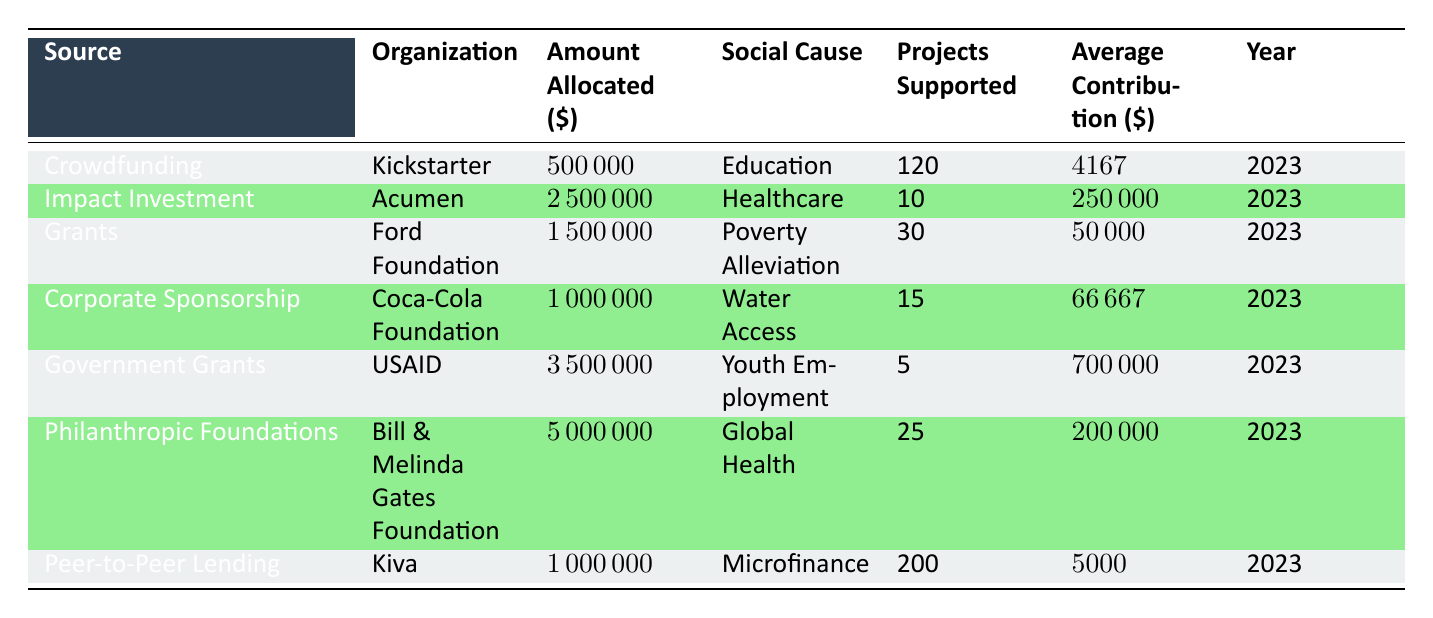What is the total amount allocated across all funding sources? To find the total amount allocated, we need to sum the Amount Allocated for each funding source. Adding them gives: 500000 + 2500000 + 1500000 + 1000000 + 3500000 + 5000000 + 1000000 = 15000000.
Answer: 15000000 Which organization allocated the most funds for social causes? By comparing the Amount Allocated across all organizations, we find that the Bill & Melinda Gates Foundation allocated 5000000, which is the highest.
Answer: Bill & Melinda Gates Foundation How many projects were supported by Acumen? Looking at the row for Acumen under Organizations, the Number of Projects Supported is 10.
Answer: 10 Is the average contribution from crowdfunding higher than from peer-to-peer lending? The average contribution for crowdfunding (4167) is compared to the average loan amount for peer-to-peer lending (5000). Since 4167 is less than 5000, the statement is false.
Answer: No What is the average amount allocated for healthcare projects supported by Acumen? Acumen allocated 2500000 for 10 projects. To find the average, divide the Amount Allocated by the Number of Projects Supported: 2500000 / 10 = 250000.
Answer: 250000 